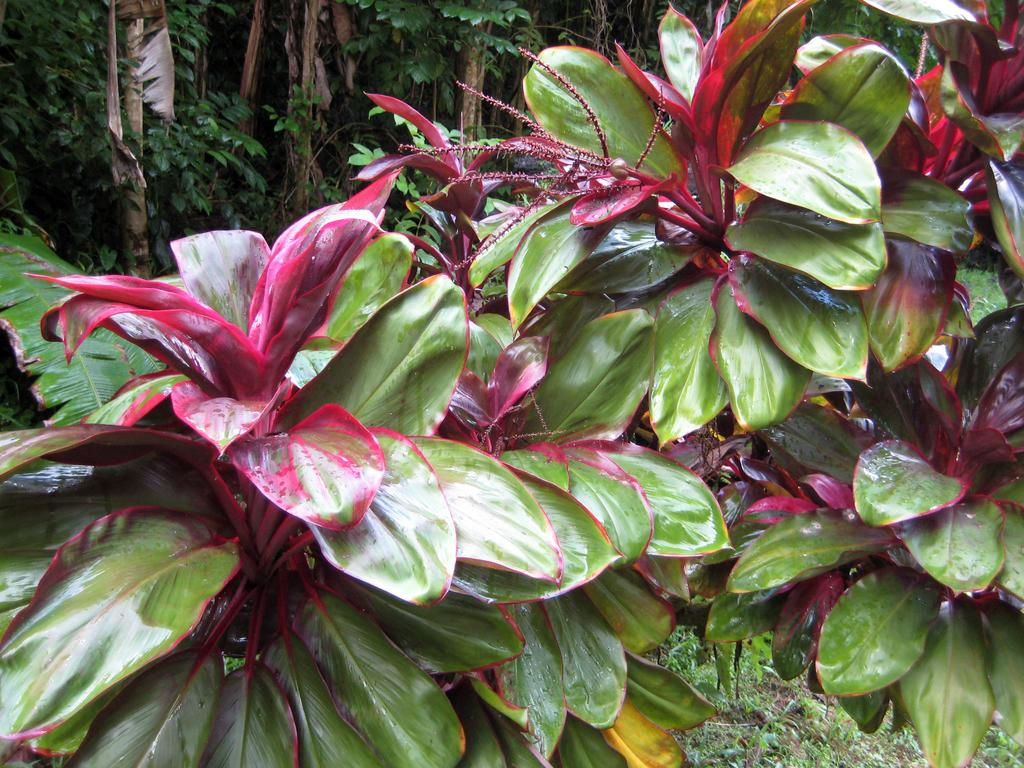What type of living organisms can be seen in the image? Plants can be seen in the image. What is visible at the bottom of the image? There is ground visible at the bottom of the image. What type of butter can be seen on the sidewalk in the image? There is no butter or sidewalk present in the image; it only features plants and ground. 